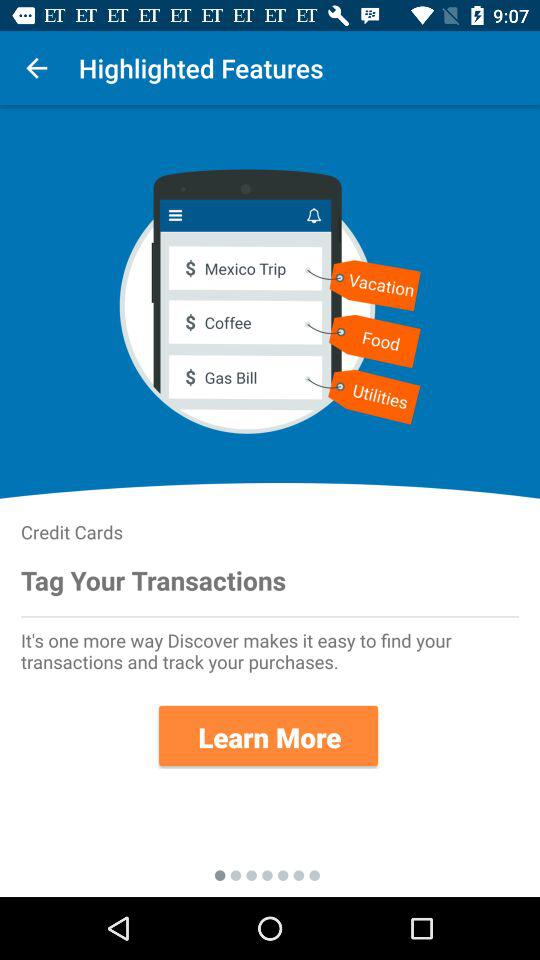Which category does the Mexico trip fall under? The Mexico trip falls under the "Vacation" category. 